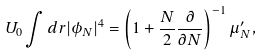<formula> <loc_0><loc_0><loc_500><loc_500>U _ { 0 } \int d { r } | \phi _ { N } | ^ { 4 } = \left ( 1 + \frac { N } { 2 } \frac { \partial } { \partial N } \right ) ^ { - 1 } \mu _ { N } ^ { \prime } ,</formula> 